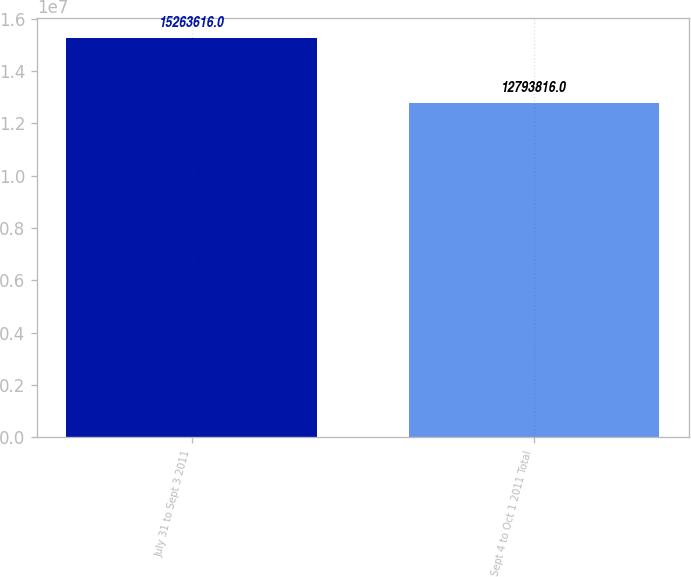Convert chart to OTSL. <chart><loc_0><loc_0><loc_500><loc_500><bar_chart><fcel>July 31 to Sept 3 2011<fcel>Sept 4 to Oct 1 2011 Total<nl><fcel>1.52636e+07<fcel>1.27938e+07<nl></chart> 